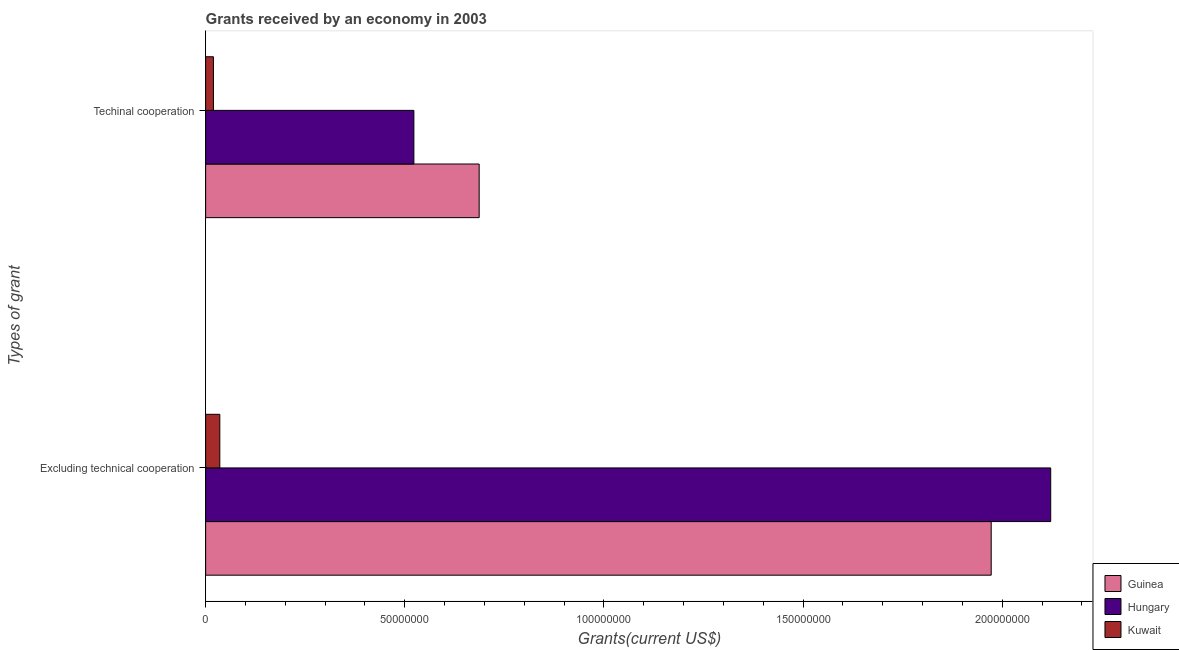How many different coloured bars are there?
Keep it short and to the point. 3. How many groups of bars are there?
Your answer should be compact. 2. Are the number of bars per tick equal to the number of legend labels?
Your answer should be compact. Yes. How many bars are there on the 2nd tick from the top?
Offer a terse response. 3. How many bars are there on the 2nd tick from the bottom?
Ensure brevity in your answer.  3. What is the label of the 1st group of bars from the top?
Provide a short and direct response. Techinal cooperation. What is the amount of grants received(including technical cooperation) in Hungary?
Provide a short and direct response. 5.23e+07. Across all countries, what is the maximum amount of grants received(excluding technical cooperation)?
Your answer should be compact. 2.12e+08. Across all countries, what is the minimum amount of grants received(including technical cooperation)?
Make the answer very short. 1.96e+06. In which country was the amount of grants received(including technical cooperation) maximum?
Ensure brevity in your answer.  Guinea. In which country was the amount of grants received(including technical cooperation) minimum?
Offer a terse response. Kuwait. What is the total amount of grants received(including technical cooperation) in the graph?
Provide a succinct answer. 1.23e+08. What is the difference between the amount of grants received(excluding technical cooperation) in Hungary and that in Guinea?
Your response must be concise. 1.49e+07. What is the difference between the amount of grants received(excluding technical cooperation) in Kuwait and the amount of grants received(including technical cooperation) in Hungary?
Offer a very short reply. -4.87e+07. What is the average amount of grants received(including technical cooperation) per country?
Make the answer very short. 4.10e+07. What is the difference between the amount of grants received(including technical cooperation) and amount of grants received(excluding technical cooperation) in Kuwait?
Your answer should be compact. -1.60e+06. What is the ratio of the amount of grants received(excluding technical cooperation) in Kuwait to that in Hungary?
Your response must be concise. 0.02. In how many countries, is the amount of grants received(including technical cooperation) greater than the average amount of grants received(including technical cooperation) taken over all countries?
Your response must be concise. 2. What does the 1st bar from the top in Excluding technical cooperation represents?
Your answer should be very brief. Kuwait. What does the 3rd bar from the bottom in Excluding technical cooperation represents?
Make the answer very short. Kuwait. How many countries are there in the graph?
Provide a short and direct response. 3. Does the graph contain any zero values?
Give a very brief answer. No. Does the graph contain grids?
Keep it short and to the point. No. Where does the legend appear in the graph?
Offer a terse response. Bottom right. How are the legend labels stacked?
Make the answer very short. Vertical. What is the title of the graph?
Make the answer very short. Grants received by an economy in 2003. Does "France" appear as one of the legend labels in the graph?
Your answer should be very brief. No. What is the label or title of the X-axis?
Your response must be concise. Grants(current US$). What is the label or title of the Y-axis?
Offer a very short reply. Types of grant. What is the Grants(current US$) in Guinea in Excluding technical cooperation?
Offer a terse response. 1.97e+08. What is the Grants(current US$) in Hungary in Excluding technical cooperation?
Your answer should be compact. 2.12e+08. What is the Grants(current US$) in Kuwait in Excluding technical cooperation?
Ensure brevity in your answer.  3.56e+06. What is the Grants(current US$) in Guinea in Techinal cooperation?
Offer a terse response. 6.87e+07. What is the Grants(current US$) of Hungary in Techinal cooperation?
Your answer should be very brief. 5.23e+07. What is the Grants(current US$) of Kuwait in Techinal cooperation?
Your response must be concise. 1.96e+06. Across all Types of grant, what is the maximum Grants(current US$) of Guinea?
Keep it short and to the point. 1.97e+08. Across all Types of grant, what is the maximum Grants(current US$) of Hungary?
Give a very brief answer. 2.12e+08. Across all Types of grant, what is the maximum Grants(current US$) of Kuwait?
Give a very brief answer. 3.56e+06. Across all Types of grant, what is the minimum Grants(current US$) of Guinea?
Offer a terse response. 6.87e+07. Across all Types of grant, what is the minimum Grants(current US$) of Hungary?
Give a very brief answer. 5.23e+07. Across all Types of grant, what is the minimum Grants(current US$) in Kuwait?
Keep it short and to the point. 1.96e+06. What is the total Grants(current US$) of Guinea in the graph?
Your response must be concise. 2.66e+08. What is the total Grants(current US$) of Hungary in the graph?
Ensure brevity in your answer.  2.64e+08. What is the total Grants(current US$) in Kuwait in the graph?
Keep it short and to the point. 5.52e+06. What is the difference between the Grants(current US$) in Guinea in Excluding technical cooperation and that in Techinal cooperation?
Your response must be concise. 1.29e+08. What is the difference between the Grants(current US$) of Hungary in Excluding technical cooperation and that in Techinal cooperation?
Offer a terse response. 1.60e+08. What is the difference between the Grants(current US$) of Kuwait in Excluding technical cooperation and that in Techinal cooperation?
Ensure brevity in your answer.  1.60e+06. What is the difference between the Grants(current US$) in Guinea in Excluding technical cooperation and the Grants(current US$) in Hungary in Techinal cooperation?
Your response must be concise. 1.45e+08. What is the difference between the Grants(current US$) in Guinea in Excluding technical cooperation and the Grants(current US$) in Kuwait in Techinal cooperation?
Your answer should be compact. 1.95e+08. What is the difference between the Grants(current US$) in Hungary in Excluding technical cooperation and the Grants(current US$) in Kuwait in Techinal cooperation?
Give a very brief answer. 2.10e+08. What is the average Grants(current US$) in Guinea per Types of grant?
Your answer should be compact. 1.33e+08. What is the average Grants(current US$) in Hungary per Types of grant?
Offer a very short reply. 1.32e+08. What is the average Grants(current US$) in Kuwait per Types of grant?
Provide a short and direct response. 2.76e+06. What is the difference between the Grants(current US$) in Guinea and Grants(current US$) in Hungary in Excluding technical cooperation?
Keep it short and to the point. -1.49e+07. What is the difference between the Grants(current US$) in Guinea and Grants(current US$) in Kuwait in Excluding technical cooperation?
Keep it short and to the point. 1.94e+08. What is the difference between the Grants(current US$) in Hungary and Grants(current US$) in Kuwait in Excluding technical cooperation?
Provide a short and direct response. 2.09e+08. What is the difference between the Grants(current US$) in Guinea and Grants(current US$) in Hungary in Techinal cooperation?
Give a very brief answer. 1.64e+07. What is the difference between the Grants(current US$) of Guinea and Grants(current US$) of Kuwait in Techinal cooperation?
Ensure brevity in your answer.  6.67e+07. What is the difference between the Grants(current US$) of Hungary and Grants(current US$) of Kuwait in Techinal cooperation?
Your answer should be compact. 5.03e+07. What is the ratio of the Grants(current US$) of Guinea in Excluding technical cooperation to that in Techinal cooperation?
Make the answer very short. 2.87. What is the ratio of the Grants(current US$) in Hungary in Excluding technical cooperation to that in Techinal cooperation?
Your answer should be very brief. 4.06. What is the ratio of the Grants(current US$) of Kuwait in Excluding technical cooperation to that in Techinal cooperation?
Provide a succinct answer. 1.82. What is the difference between the highest and the second highest Grants(current US$) in Guinea?
Provide a short and direct response. 1.29e+08. What is the difference between the highest and the second highest Grants(current US$) of Hungary?
Give a very brief answer. 1.60e+08. What is the difference between the highest and the second highest Grants(current US$) in Kuwait?
Keep it short and to the point. 1.60e+06. What is the difference between the highest and the lowest Grants(current US$) in Guinea?
Your answer should be compact. 1.29e+08. What is the difference between the highest and the lowest Grants(current US$) in Hungary?
Make the answer very short. 1.60e+08. What is the difference between the highest and the lowest Grants(current US$) in Kuwait?
Give a very brief answer. 1.60e+06. 